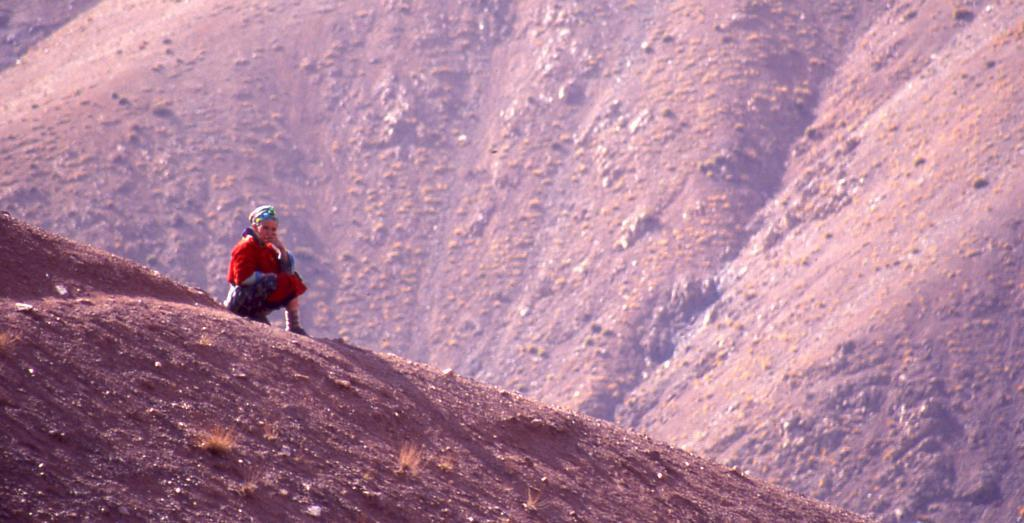Who is the main subject in the image? There is a lady in the image. What is the lady wearing? The lady is wearing a red dress. What can be seen in the background of the image? There are mountains in the background of the image. What type of surface is visible at the bottom of the image? There is a surface with dry grass at the bottom of the image. What type of stew is being prepared on the grassy surface in the image? There is no stew or cooking activity present in the image; it features a lady in a red dress with mountains in the background. Can you see any fangs on the lady in the image? There are no fangs visible on the lady in the image; she is simply wearing a red dress. 